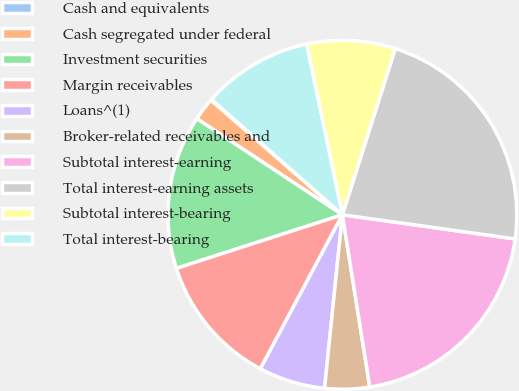<chart> <loc_0><loc_0><loc_500><loc_500><pie_chart><fcel>Cash and equivalents<fcel>Cash segregated under federal<fcel>Investment securities<fcel>Margin receivables<fcel>Loans^(1)<fcel>Broker-related receivables and<fcel>Subtotal interest-earning<fcel>Total interest-earning assets<fcel>Subtotal interest-bearing<fcel>Total interest-bearing<nl><fcel>0.09%<fcel>2.12%<fcel>14.26%<fcel>12.24%<fcel>6.16%<fcel>4.14%<fcel>20.28%<fcel>22.31%<fcel>8.19%<fcel>10.21%<nl></chart> 